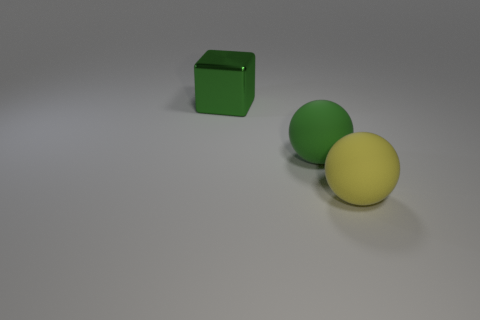What is the color of the rubber ball that is the same size as the yellow rubber thing?
Your response must be concise. Green. Is there a large rubber thing of the same color as the shiny block?
Make the answer very short. Yes. Do the matte object that is on the left side of the yellow matte ball and the object on the left side of the green ball have the same color?
Make the answer very short. Yes. What material is the object to the right of the green ball?
Ensure brevity in your answer.  Rubber. The object that is the same material as the yellow sphere is what color?
Offer a terse response. Green. What number of red metal cylinders are the same size as the yellow rubber ball?
Provide a succinct answer. 0. What shape is the large object that is to the right of the shiny thing and on the left side of the yellow object?
Your answer should be very brief. Sphere. There is a large green block; are there any rubber objects right of it?
Offer a terse response. Yes. Is there any other thing that has the same shape as the big green metal object?
Your answer should be compact. No. Is the yellow matte thing the same shape as the big green rubber object?
Give a very brief answer. Yes. 